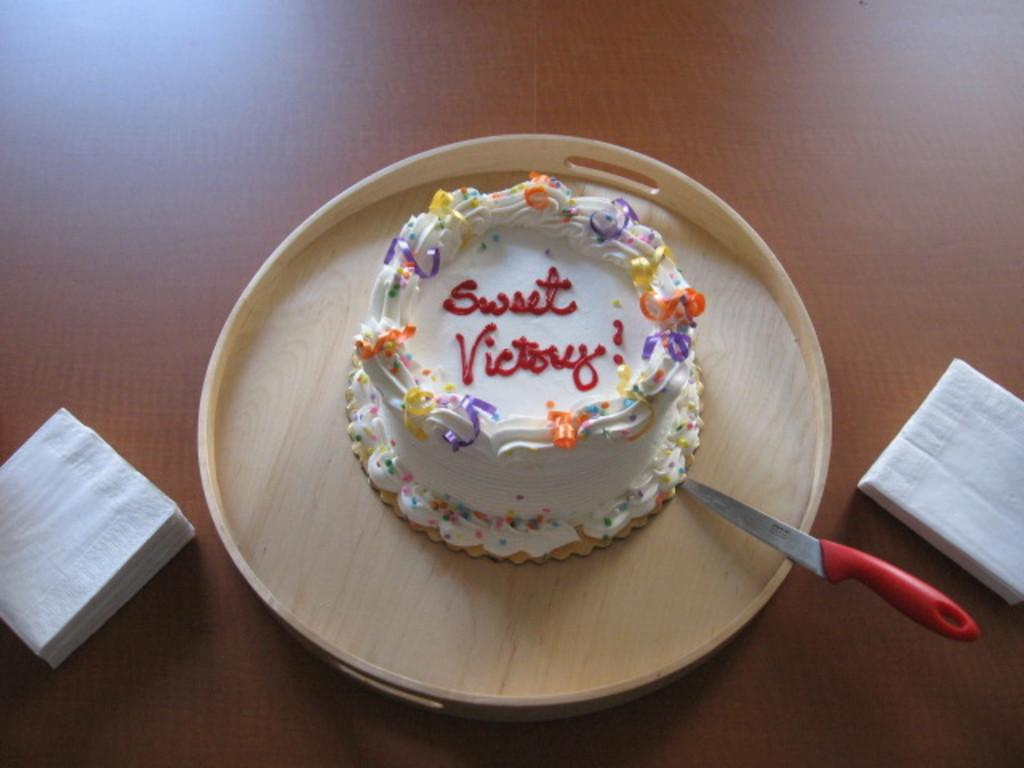What is the main food item featured in the image? There is a cake in the image. What object is placed on a plate in the image? There is a knife on a plate in the image. What type of item is present on the table in the image? There are tissues on the table in the image. Can you see a snail crawling on the cake in the image? No, there is no snail present in the image. What type of scale is used to weigh the cake in the image? There is no scale present in the image, and the weight of the cake is not mentioned. 